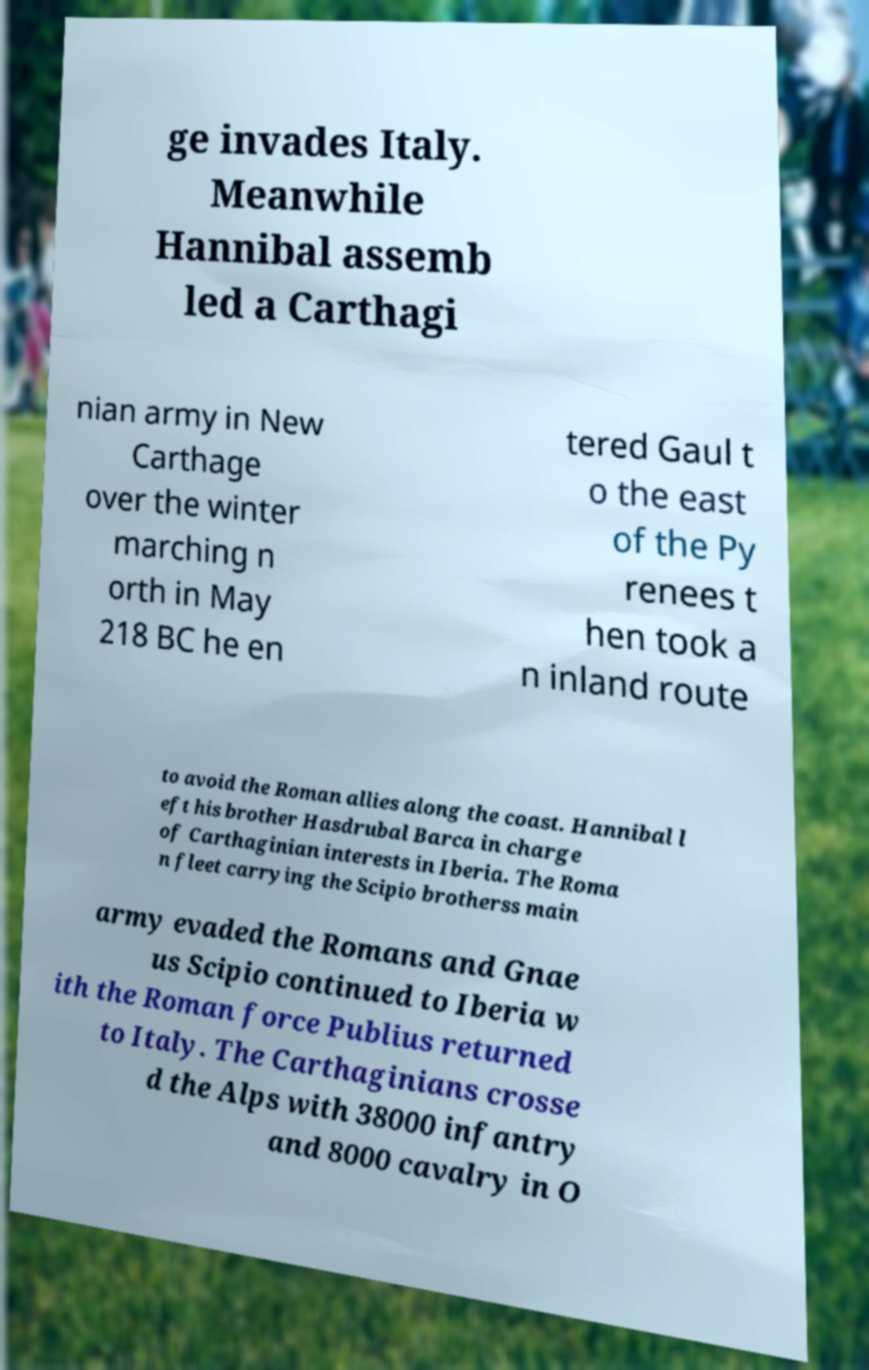Could you extract and type out the text from this image? ge invades Italy. Meanwhile Hannibal assemb led a Carthagi nian army in New Carthage over the winter marching n orth in May 218 BC he en tered Gaul t o the east of the Py renees t hen took a n inland route to avoid the Roman allies along the coast. Hannibal l eft his brother Hasdrubal Barca in charge of Carthaginian interests in Iberia. The Roma n fleet carrying the Scipio brotherss main army evaded the Romans and Gnae us Scipio continued to Iberia w ith the Roman force Publius returned to Italy. The Carthaginians crosse d the Alps with 38000 infantry and 8000 cavalry in O 